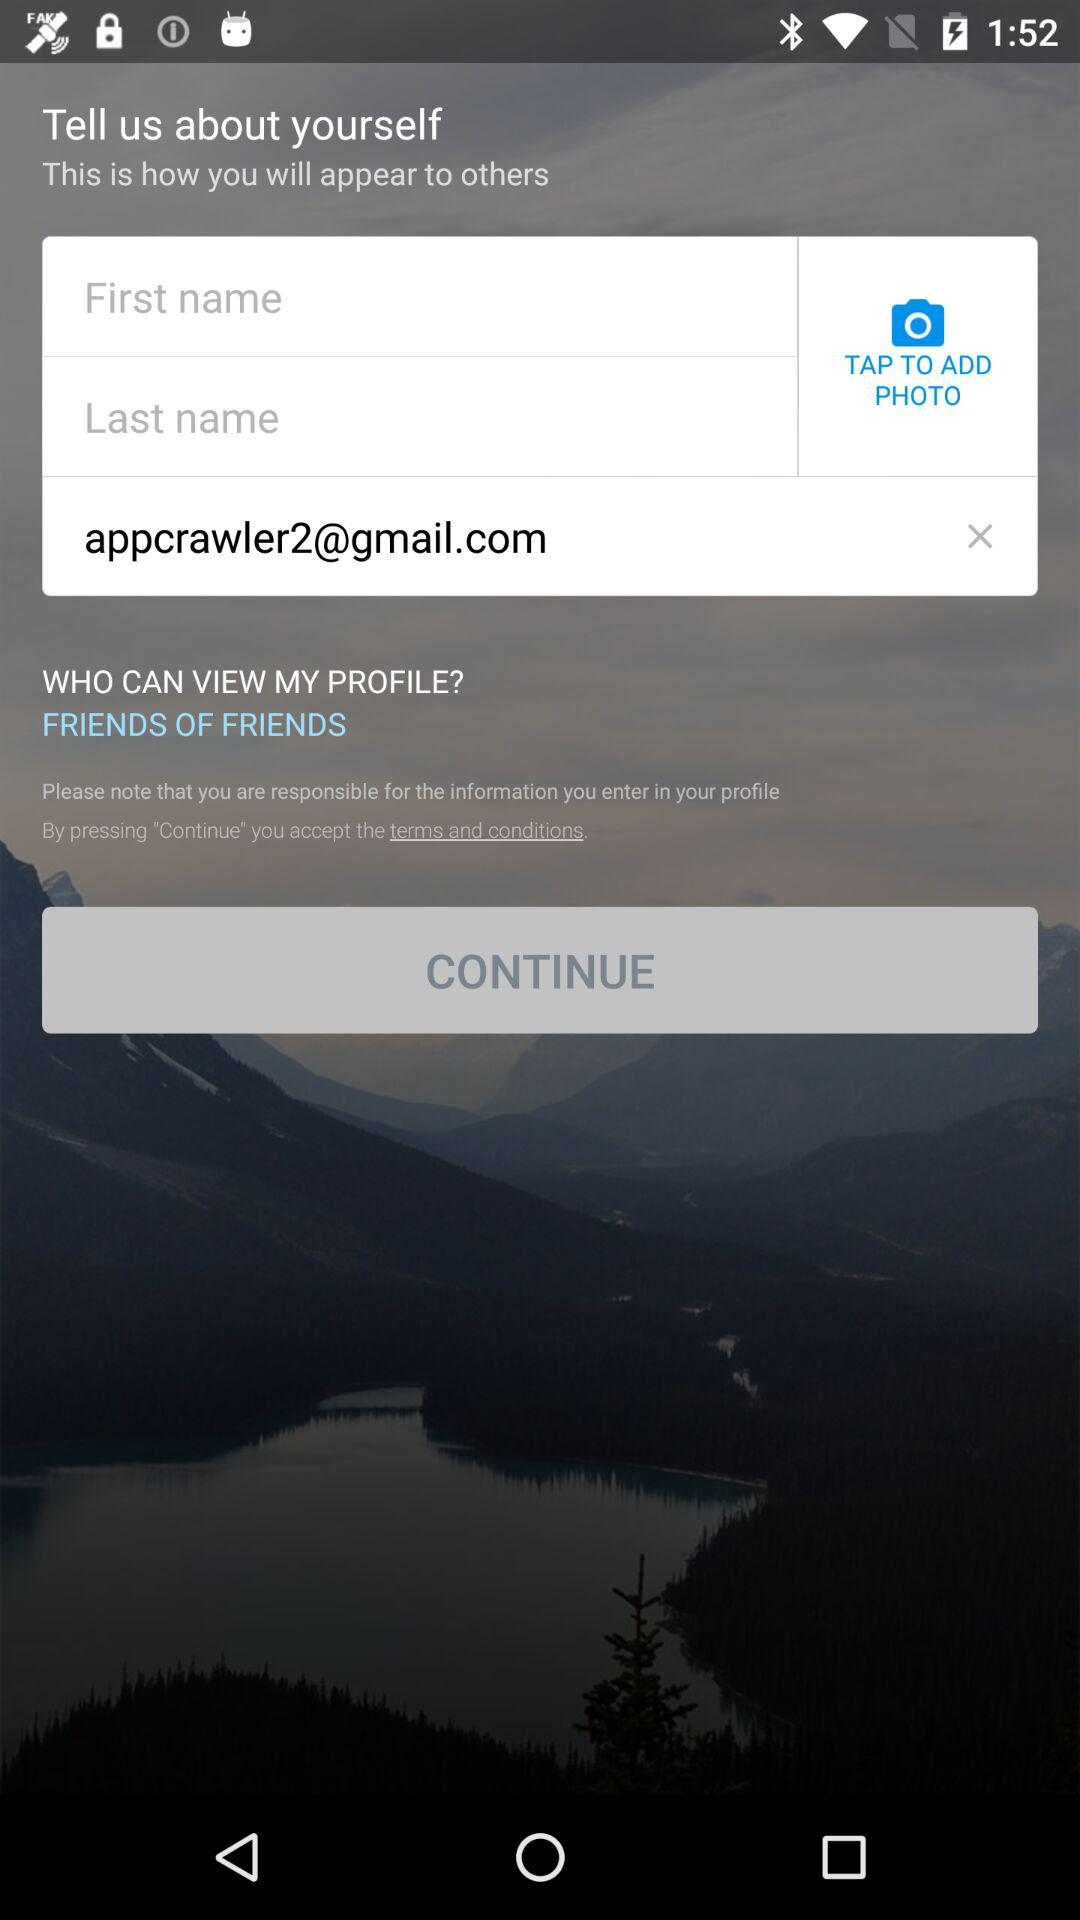What is the setting for "WHO CAN VIEW MY PROFILE"? The setting is "FRIENDS OF FRIENDS". 